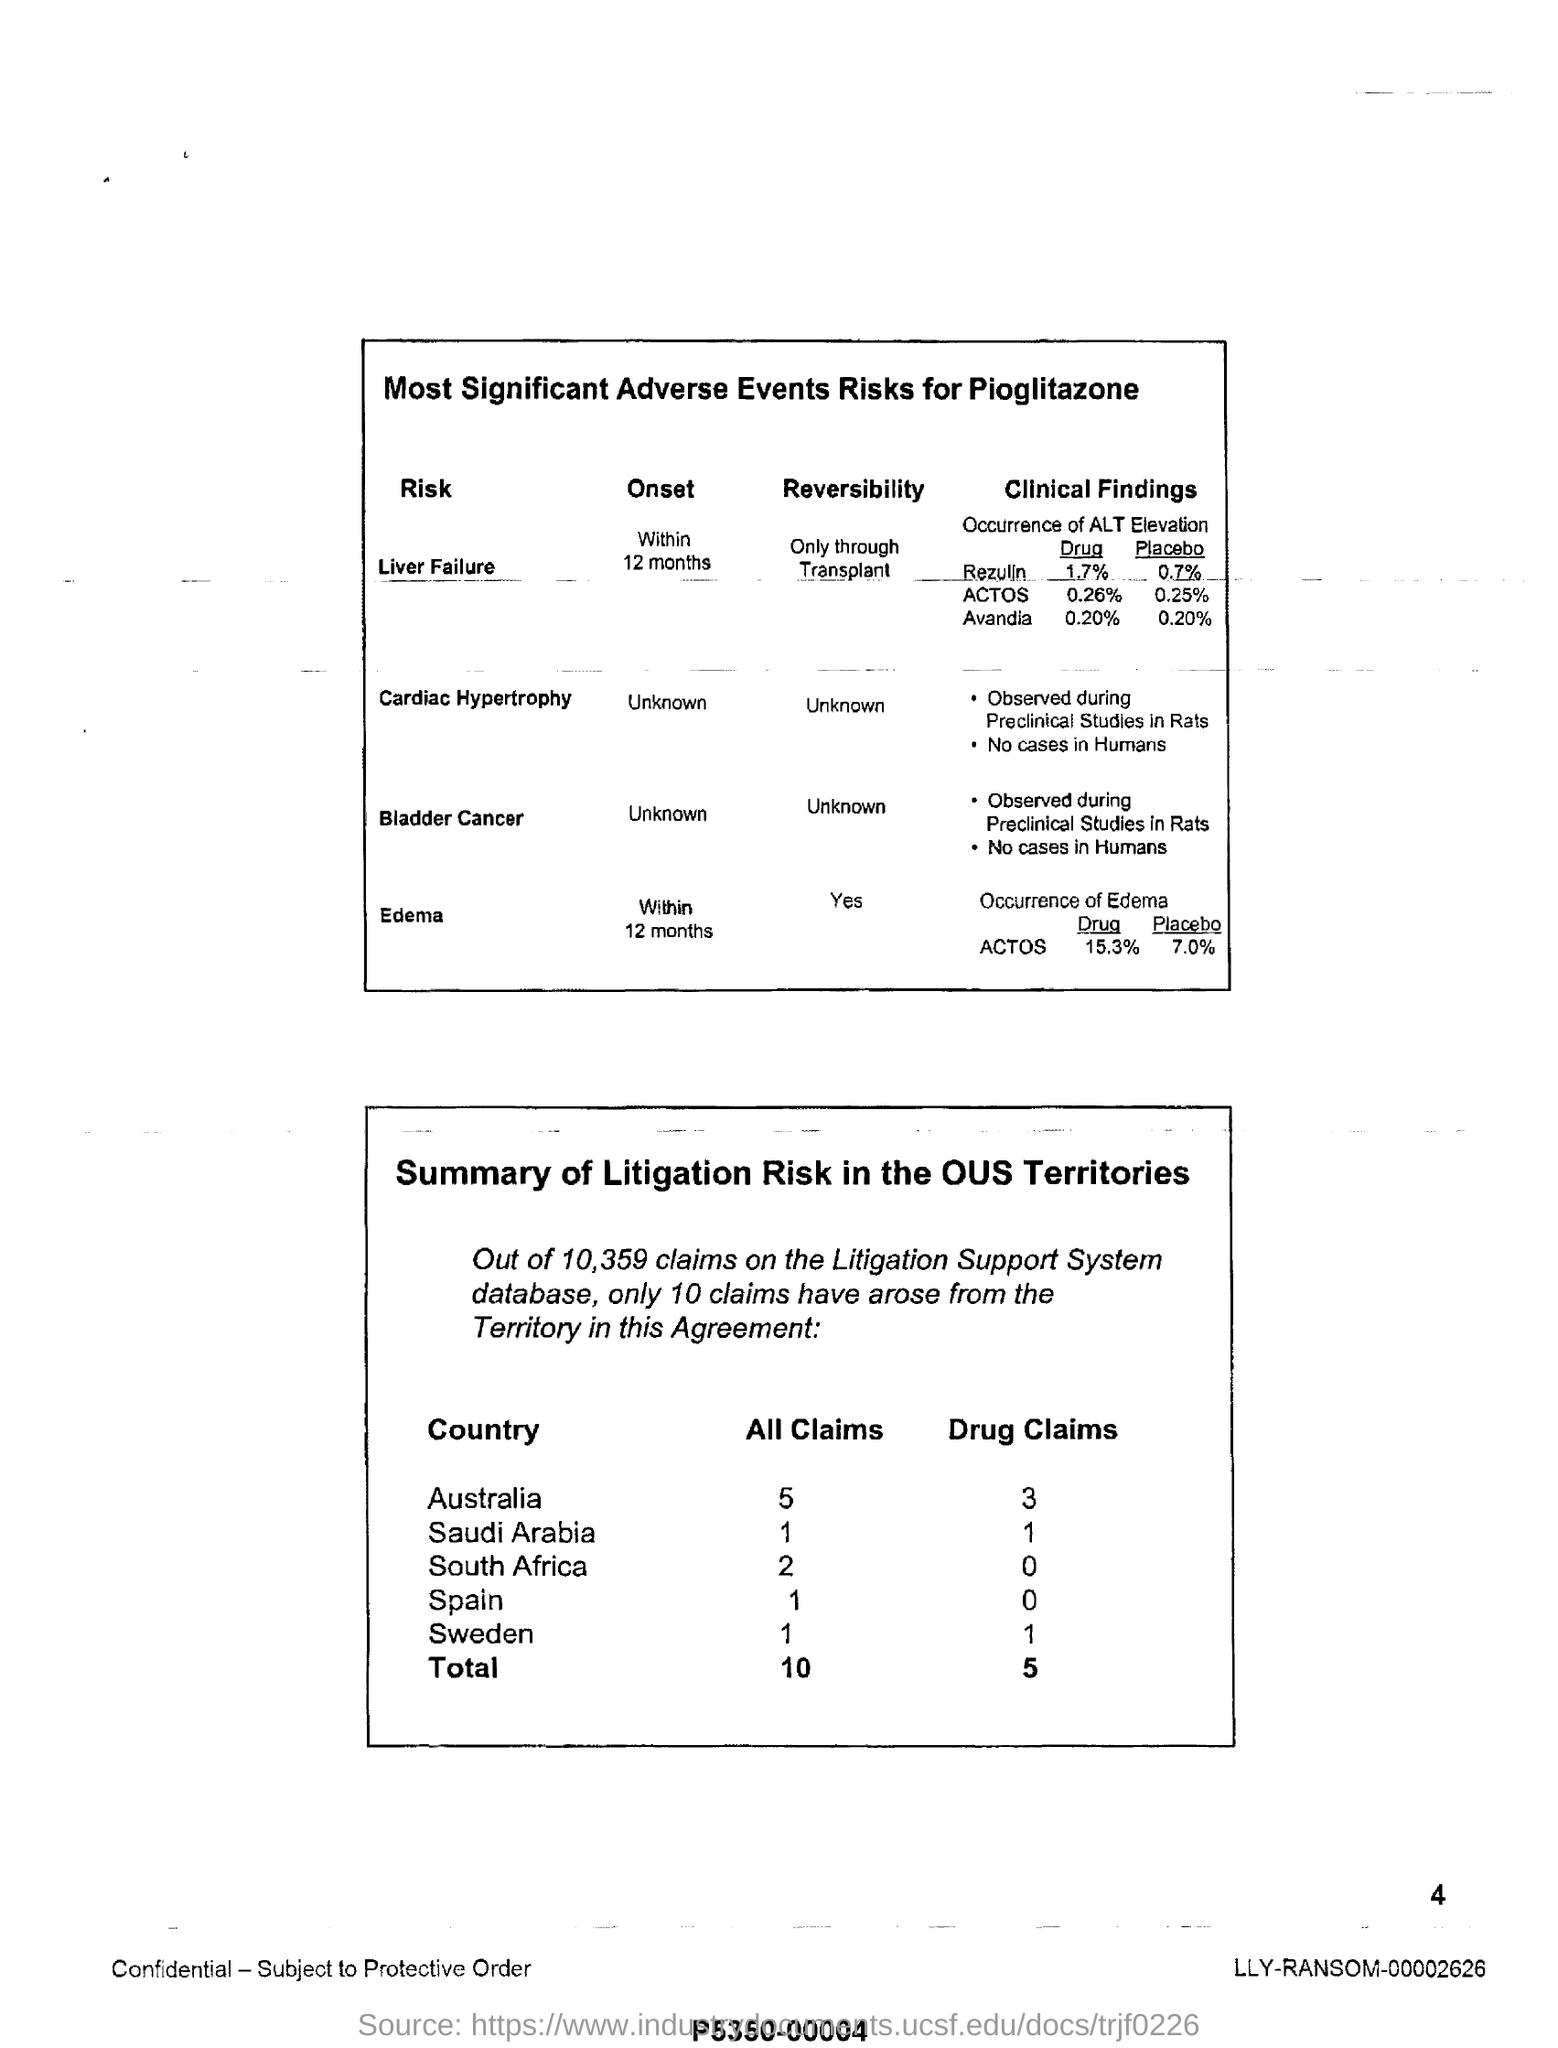What is the first point given in table for bladder cancer alongside of  clinical findings ?
Provide a succinct answer. OBSERVED DURING PRECLINICAL STUDIES IN RATS. How much percent of  drug quantity present in rezulin under the title of 'clinical findings'?
Provide a short and direct response. 1.7. How much percent of placebo present in avandia alongside of the clinical findings?
Ensure brevity in your answer.  0.20. What is the total number of all claims under the title of "summary of litigation risk in the ous territories"?
Offer a terse response. 10. What is the total number of drug claims under the title of "summary  of litigation risk in the ous territories"?
Make the answer very short. 5. 